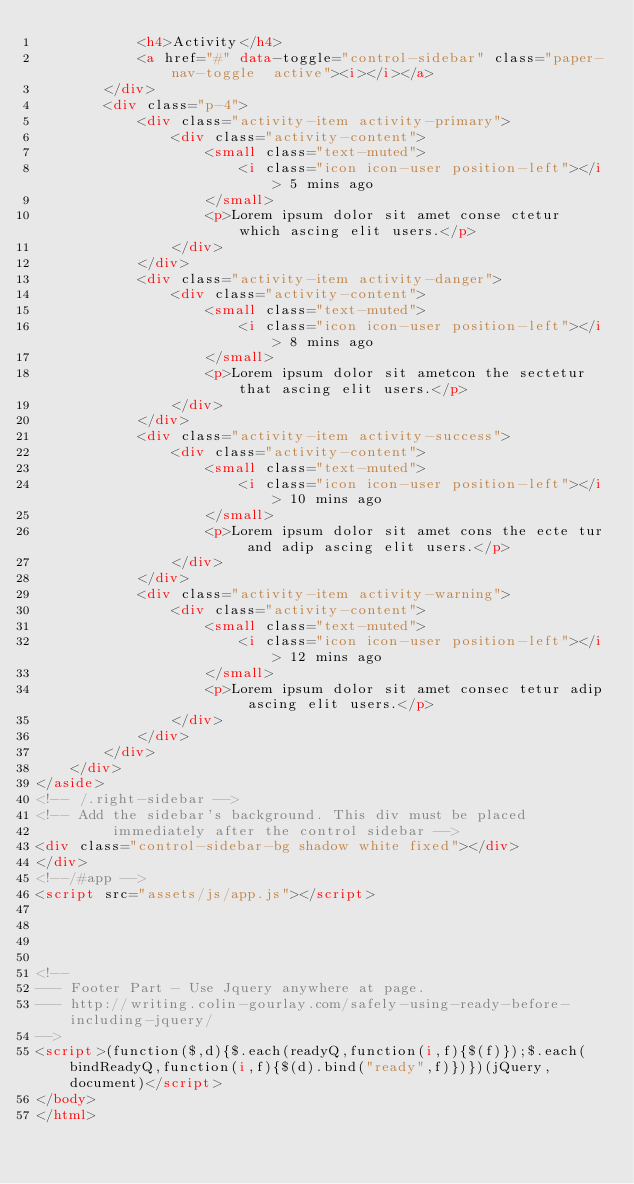Convert code to text. <code><loc_0><loc_0><loc_500><loc_500><_HTML_>            <h4>Activity</h4>
            <a href="#" data-toggle="control-sidebar" class="paper-nav-toggle  active"><i></i></a>
        </div>
        <div class="p-4">
            <div class="activity-item activity-primary">
                <div class="activity-content">
                    <small class="text-muted">
                        <i class="icon icon-user position-left"></i> 5 mins ago
                    </small>
                    <p>Lorem ipsum dolor sit amet conse ctetur which ascing elit users.</p>
                </div>
            </div>
            <div class="activity-item activity-danger">
                <div class="activity-content">
                    <small class="text-muted">
                        <i class="icon icon-user position-left"></i> 8 mins ago
                    </small>
                    <p>Lorem ipsum dolor sit ametcon the sectetur that ascing elit users.</p>
                </div>
            </div>
            <div class="activity-item activity-success">
                <div class="activity-content">
                    <small class="text-muted">
                        <i class="icon icon-user position-left"></i> 10 mins ago
                    </small>
                    <p>Lorem ipsum dolor sit amet cons the ecte tur and adip ascing elit users.</p>
                </div>
            </div>
            <div class="activity-item activity-warning">
                <div class="activity-content">
                    <small class="text-muted">
                        <i class="icon icon-user position-left"></i> 12 mins ago
                    </small>
                    <p>Lorem ipsum dolor sit amet consec tetur adip ascing elit users.</p>
                </div>
            </div>
        </div>
    </div>
</aside>
<!-- /.right-sidebar -->
<!-- Add the sidebar's background. This div must be placed
         immediately after the control sidebar -->
<div class="control-sidebar-bg shadow white fixed"></div>
</div>
<!--/#app -->
<script src="assets/js/app.js"></script>




<!--
--- Footer Part - Use Jquery anywhere at page.
--- http://writing.colin-gourlay.com/safely-using-ready-before-including-jquery/
-->
<script>(function($,d){$.each(readyQ,function(i,f){$(f)});$.each(bindReadyQ,function(i,f){$(d).bind("ready",f)})})(jQuery,document)</script>
</body>
</html></code> 